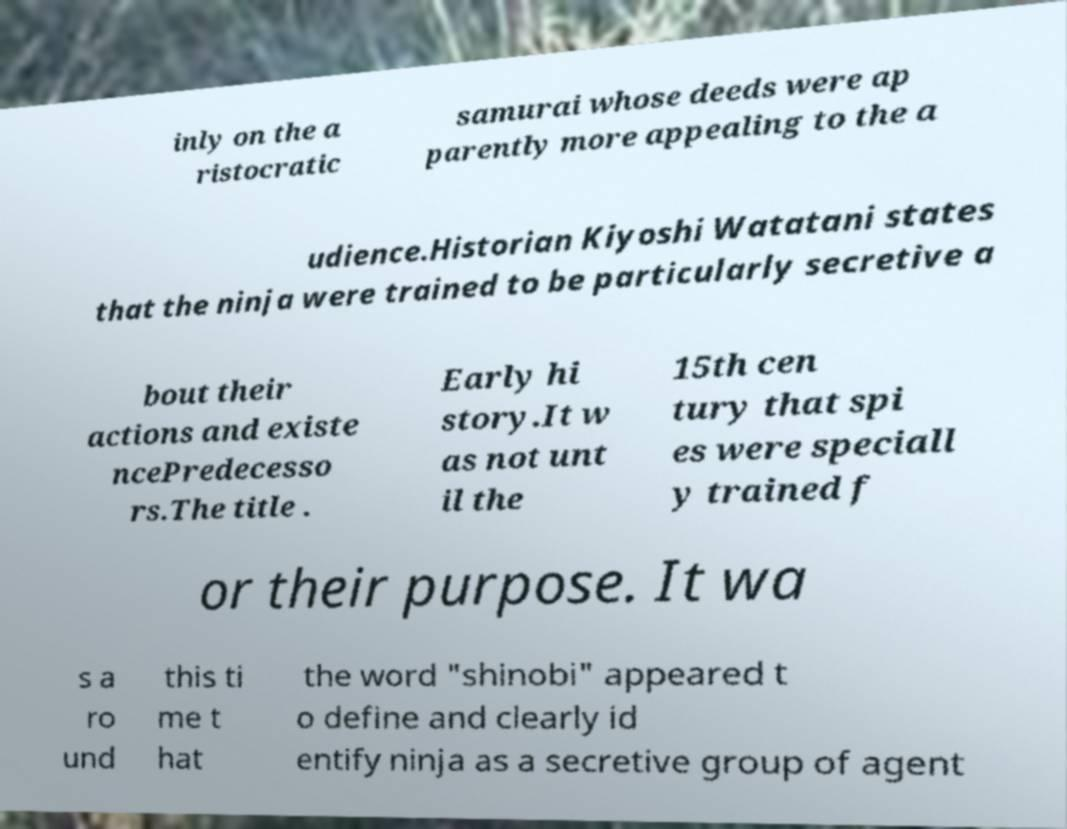I need the written content from this picture converted into text. Can you do that? inly on the a ristocratic samurai whose deeds were ap parently more appealing to the a udience.Historian Kiyoshi Watatani states that the ninja were trained to be particularly secretive a bout their actions and existe ncePredecesso rs.The title . Early hi story.It w as not unt il the 15th cen tury that spi es were speciall y trained f or their purpose. It wa s a ro und this ti me t hat the word "shinobi" appeared t o define and clearly id entify ninja as a secretive group of agent 